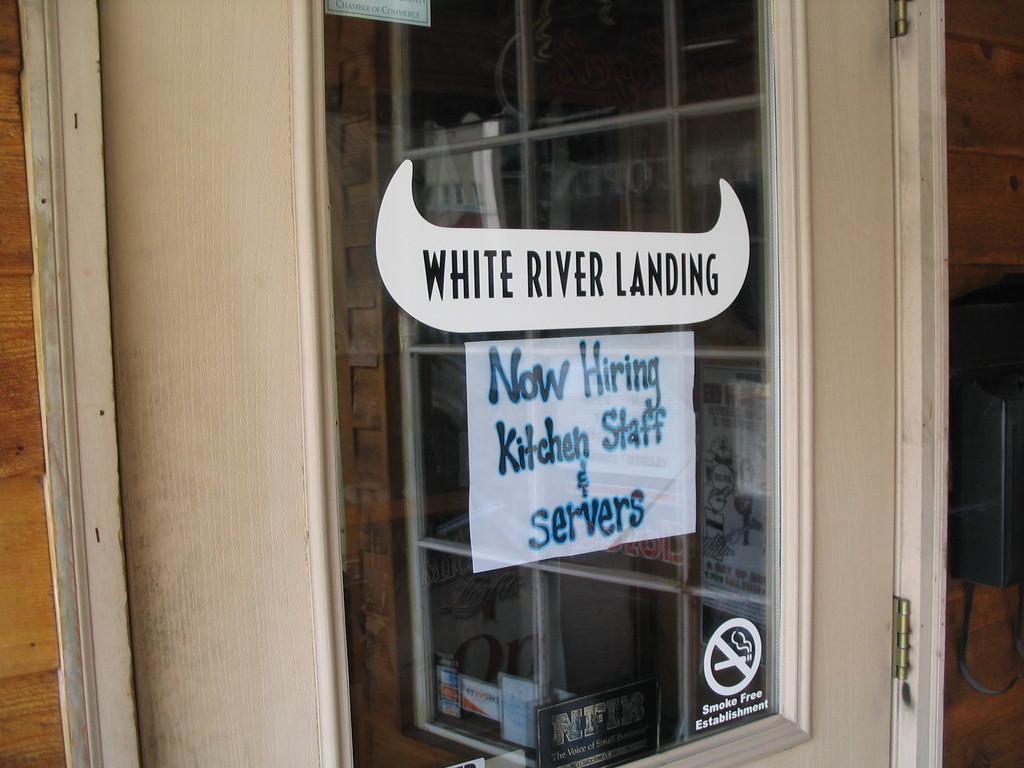Describe this image in one or two sentences. In this image we can see the wall, and a window, on the window we can see posters and stickers with text on it. 